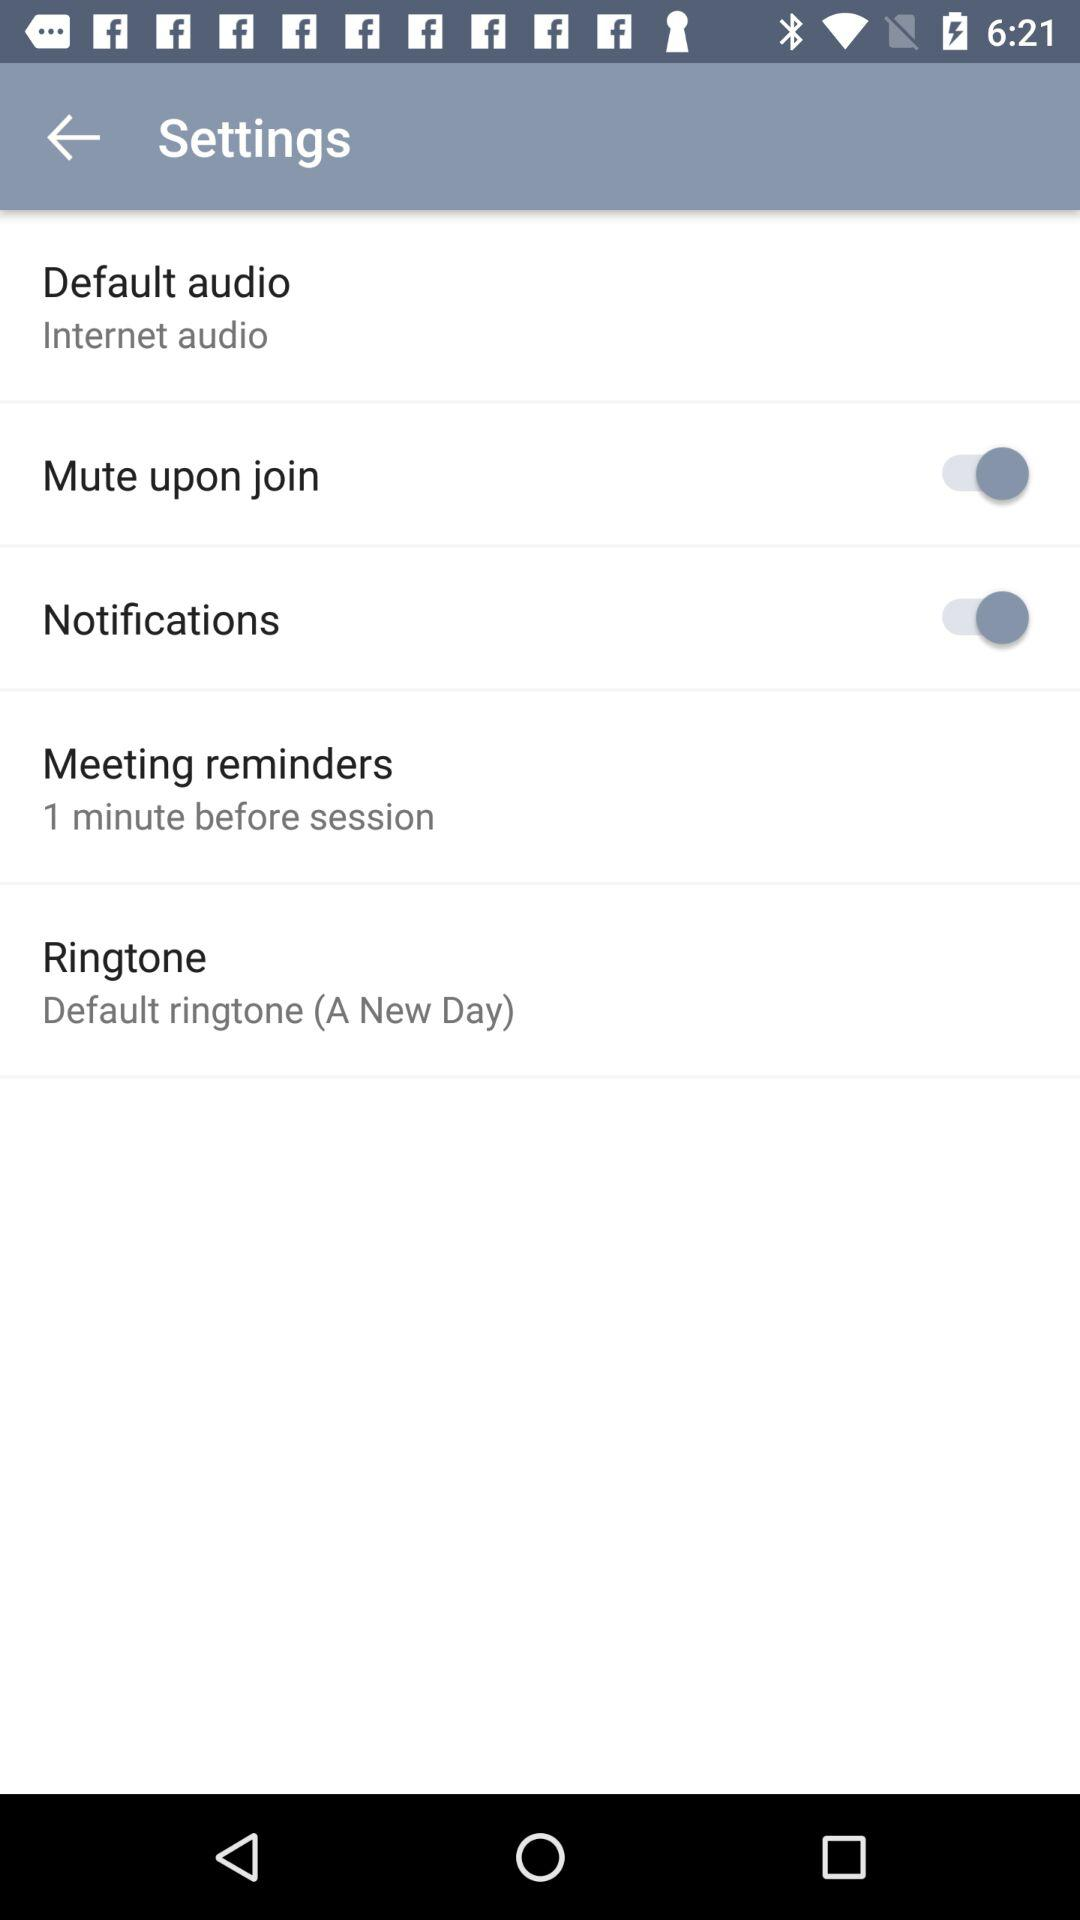What default audio is set? The default audio is "Internet audio". 